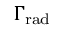<formula> <loc_0><loc_0><loc_500><loc_500>\Gamma _ { r a d }</formula> 